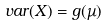<formula> <loc_0><loc_0><loc_500><loc_500>v a r ( X ) = g ( \mu )</formula> 